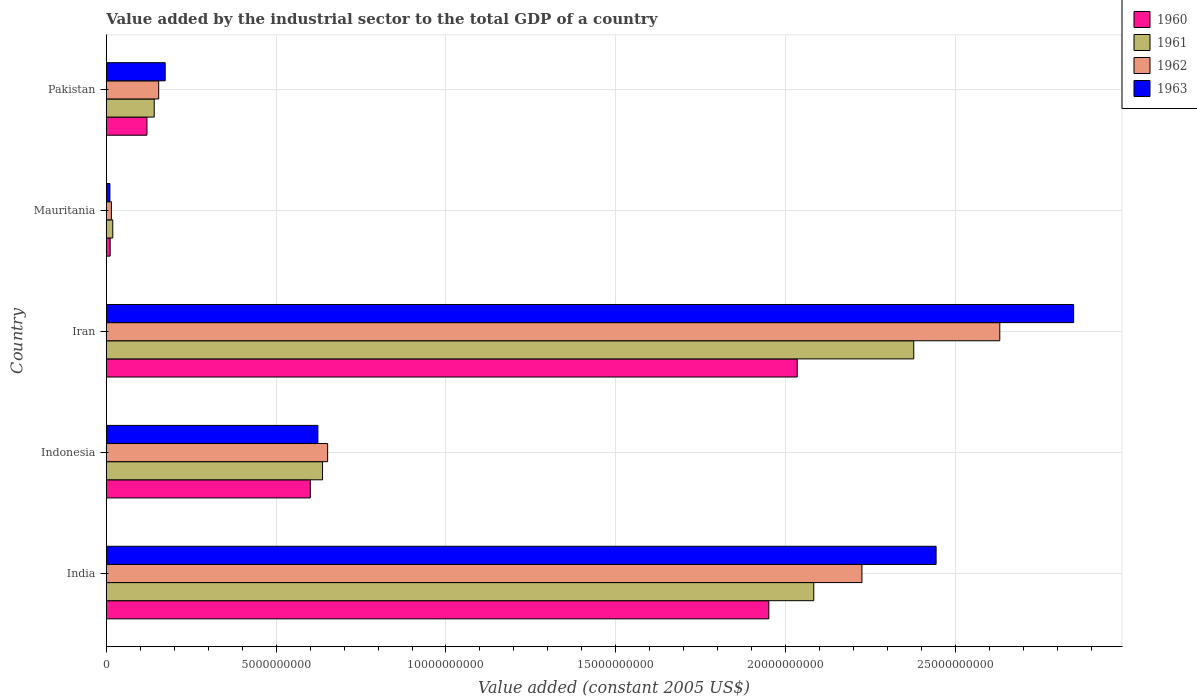How many different coloured bars are there?
Your response must be concise. 4. How many groups of bars are there?
Make the answer very short. 5. Are the number of bars per tick equal to the number of legend labels?
Your response must be concise. Yes. Are the number of bars on each tick of the Y-axis equal?
Keep it short and to the point. Yes. How many bars are there on the 5th tick from the bottom?
Offer a very short reply. 4. What is the value added by the industrial sector in 1960 in Mauritania?
Your answer should be very brief. 1.15e+08. Across all countries, what is the maximum value added by the industrial sector in 1960?
Your response must be concise. 2.03e+1. Across all countries, what is the minimum value added by the industrial sector in 1962?
Give a very brief answer. 1.51e+08. In which country was the value added by the industrial sector in 1963 maximum?
Make the answer very short. Iran. In which country was the value added by the industrial sector in 1963 minimum?
Your answer should be compact. Mauritania. What is the total value added by the industrial sector in 1962 in the graph?
Provide a succinct answer. 5.68e+1. What is the difference between the value added by the industrial sector in 1960 in India and that in Mauritania?
Your response must be concise. 1.94e+1. What is the difference between the value added by the industrial sector in 1961 in Indonesia and the value added by the industrial sector in 1962 in Pakistan?
Provide a short and direct response. 4.82e+09. What is the average value added by the industrial sector in 1960 per country?
Your answer should be compact. 9.43e+09. What is the difference between the value added by the industrial sector in 1961 and value added by the industrial sector in 1962 in India?
Make the answer very short. -1.42e+09. What is the ratio of the value added by the industrial sector in 1963 in India to that in Mauritania?
Your answer should be compact. 225.7. Is the value added by the industrial sector in 1961 in India less than that in Pakistan?
Your answer should be very brief. No. Is the difference between the value added by the industrial sector in 1961 in Iran and Pakistan greater than the difference between the value added by the industrial sector in 1962 in Iran and Pakistan?
Make the answer very short. No. What is the difference between the highest and the second highest value added by the industrial sector in 1960?
Keep it short and to the point. 8.36e+08. What is the difference between the highest and the lowest value added by the industrial sector in 1961?
Offer a terse response. 2.36e+1. Is it the case that in every country, the sum of the value added by the industrial sector in 1960 and value added by the industrial sector in 1962 is greater than the value added by the industrial sector in 1961?
Provide a short and direct response. Yes. How many bars are there?
Offer a terse response. 20. How many countries are there in the graph?
Make the answer very short. 5. What is the difference between two consecutive major ticks on the X-axis?
Provide a succinct answer. 5.00e+09. How many legend labels are there?
Offer a very short reply. 4. How are the legend labels stacked?
Provide a short and direct response. Vertical. What is the title of the graph?
Offer a terse response. Value added by the industrial sector to the total GDP of a country. What is the label or title of the X-axis?
Keep it short and to the point. Value added (constant 2005 US$). What is the label or title of the Y-axis?
Ensure brevity in your answer.  Country. What is the Value added (constant 2005 US$) in 1960 in India?
Offer a very short reply. 1.95e+1. What is the Value added (constant 2005 US$) in 1961 in India?
Provide a short and direct response. 2.08e+1. What is the Value added (constant 2005 US$) in 1962 in India?
Your answer should be compact. 2.22e+1. What is the Value added (constant 2005 US$) in 1963 in India?
Your answer should be very brief. 2.44e+1. What is the Value added (constant 2005 US$) of 1960 in Indonesia?
Provide a short and direct response. 6.01e+09. What is the Value added (constant 2005 US$) in 1961 in Indonesia?
Give a very brief answer. 6.37e+09. What is the Value added (constant 2005 US$) in 1962 in Indonesia?
Your answer should be very brief. 6.52e+09. What is the Value added (constant 2005 US$) of 1963 in Indonesia?
Your answer should be compact. 6.23e+09. What is the Value added (constant 2005 US$) in 1960 in Iran?
Ensure brevity in your answer.  2.03e+1. What is the Value added (constant 2005 US$) of 1961 in Iran?
Offer a terse response. 2.38e+1. What is the Value added (constant 2005 US$) of 1962 in Iran?
Your answer should be very brief. 2.63e+1. What is the Value added (constant 2005 US$) in 1963 in Iran?
Make the answer very short. 2.85e+1. What is the Value added (constant 2005 US$) in 1960 in Mauritania?
Your answer should be very brief. 1.15e+08. What is the Value added (constant 2005 US$) in 1961 in Mauritania?
Keep it short and to the point. 1.92e+08. What is the Value added (constant 2005 US$) of 1962 in Mauritania?
Give a very brief answer. 1.51e+08. What is the Value added (constant 2005 US$) in 1963 in Mauritania?
Provide a succinct answer. 1.08e+08. What is the Value added (constant 2005 US$) in 1960 in Pakistan?
Give a very brief answer. 1.20e+09. What is the Value added (constant 2005 US$) in 1961 in Pakistan?
Your answer should be very brief. 1.41e+09. What is the Value added (constant 2005 US$) in 1962 in Pakistan?
Your response must be concise. 1.54e+09. What is the Value added (constant 2005 US$) of 1963 in Pakistan?
Keep it short and to the point. 1.74e+09. Across all countries, what is the maximum Value added (constant 2005 US$) in 1960?
Provide a short and direct response. 2.03e+1. Across all countries, what is the maximum Value added (constant 2005 US$) of 1961?
Your answer should be compact. 2.38e+1. Across all countries, what is the maximum Value added (constant 2005 US$) of 1962?
Ensure brevity in your answer.  2.63e+1. Across all countries, what is the maximum Value added (constant 2005 US$) of 1963?
Provide a succinct answer. 2.85e+1. Across all countries, what is the minimum Value added (constant 2005 US$) in 1960?
Make the answer very short. 1.15e+08. Across all countries, what is the minimum Value added (constant 2005 US$) of 1961?
Offer a very short reply. 1.92e+08. Across all countries, what is the minimum Value added (constant 2005 US$) of 1962?
Give a very brief answer. 1.51e+08. Across all countries, what is the minimum Value added (constant 2005 US$) in 1963?
Your response must be concise. 1.08e+08. What is the total Value added (constant 2005 US$) of 1960 in the graph?
Provide a short and direct response. 4.72e+1. What is the total Value added (constant 2005 US$) of 1961 in the graph?
Give a very brief answer. 5.26e+1. What is the total Value added (constant 2005 US$) of 1962 in the graph?
Provide a succinct answer. 5.68e+1. What is the total Value added (constant 2005 US$) in 1963 in the graph?
Offer a very short reply. 6.10e+1. What is the difference between the Value added (constant 2005 US$) in 1960 in India and that in Indonesia?
Your answer should be very brief. 1.35e+1. What is the difference between the Value added (constant 2005 US$) of 1961 in India and that in Indonesia?
Offer a very short reply. 1.45e+1. What is the difference between the Value added (constant 2005 US$) of 1962 in India and that in Indonesia?
Ensure brevity in your answer.  1.57e+1. What is the difference between the Value added (constant 2005 US$) in 1963 in India and that in Indonesia?
Make the answer very short. 1.82e+1. What is the difference between the Value added (constant 2005 US$) of 1960 in India and that in Iran?
Ensure brevity in your answer.  -8.36e+08. What is the difference between the Value added (constant 2005 US$) of 1961 in India and that in Iran?
Provide a short and direct response. -2.94e+09. What is the difference between the Value added (constant 2005 US$) in 1962 in India and that in Iran?
Offer a very short reply. -4.06e+09. What is the difference between the Value added (constant 2005 US$) in 1963 in India and that in Iran?
Your answer should be very brief. -4.05e+09. What is the difference between the Value added (constant 2005 US$) of 1960 in India and that in Mauritania?
Keep it short and to the point. 1.94e+1. What is the difference between the Value added (constant 2005 US$) in 1961 in India and that in Mauritania?
Ensure brevity in your answer.  2.06e+1. What is the difference between the Value added (constant 2005 US$) in 1962 in India and that in Mauritania?
Provide a succinct answer. 2.21e+1. What is the difference between the Value added (constant 2005 US$) in 1963 in India and that in Mauritania?
Your answer should be compact. 2.43e+1. What is the difference between the Value added (constant 2005 US$) of 1960 in India and that in Pakistan?
Your response must be concise. 1.83e+1. What is the difference between the Value added (constant 2005 US$) in 1961 in India and that in Pakistan?
Provide a short and direct response. 1.94e+1. What is the difference between the Value added (constant 2005 US$) in 1962 in India and that in Pakistan?
Your response must be concise. 2.07e+1. What is the difference between the Value added (constant 2005 US$) in 1963 in India and that in Pakistan?
Your response must be concise. 2.27e+1. What is the difference between the Value added (constant 2005 US$) in 1960 in Indonesia and that in Iran?
Your answer should be very brief. -1.43e+1. What is the difference between the Value added (constant 2005 US$) of 1961 in Indonesia and that in Iran?
Provide a succinct answer. -1.74e+1. What is the difference between the Value added (constant 2005 US$) in 1962 in Indonesia and that in Iran?
Provide a succinct answer. -1.98e+1. What is the difference between the Value added (constant 2005 US$) in 1963 in Indonesia and that in Iran?
Your answer should be very brief. -2.22e+1. What is the difference between the Value added (constant 2005 US$) in 1960 in Indonesia and that in Mauritania?
Make the answer very short. 5.89e+09. What is the difference between the Value added (constant 2005 US$) in 1961 in Indonesia and that in Mauritania?
Offer a very short reply. 6.17e+09. What is the difference between the Value added (constant 2005 US$) of 1962 in Indonesia and that in Mauritania?
Offer a terse response. 6.37e+09. What is the difference between the Value added (constant 2005 US$) of 1963 in Indonesia and that in Mauritania?
Provide a short and direct response. 6.12e+09. What is the difference between the Value added (constant 2005 US$) in 1960 in Indonesia and that in Pakistan?
Provide a short and direct response. 4.81e+09. What is the difference between the Value added (constant 2005 US$) in 1961 in Indonesia and that in Pakistan?
Offer a very short reply. 4.96e+09. What is the difference between the Value added (constant 2005 US$) of 1962 in Indonesia and that in Pakistan?
Give a very brief answer. 4.97e+09. What is the difference between the Value added (constant 2005 US$) of 1963 in Indonesia and that in Pakistan?
Offer a very short reply. 4.49e+09. What is the difference between the Value added (constant 2005 US$) of 1960 in Iran and that in Mauritania?
Offer a terse response. 2.02e+1. What is the difference between the Value added (constant 2005 US$) of 1961 in Iran and that in Mauritania?
Your answer should be very brief. 2.36e+1. What is the difference between the Value added (constant 2005 US$) of 1962 in Iran and that in Mauritania?
Provide a short and direct response. 2.62e+1. What is the difference between the Value added (constant 2005 US$) of 1963 in Iran and that in Mauritania?
Provide a succinct answer. 2.84e+1. What is the difference between the Value added (constant 2005 US$) of 1960 in Iran and that in Pakistan?
Offer a terse response. 1.91e+1. What is the difference between the Value added (constant 2005 US$) in 1961 in Iran and that in Pakistan?
Give a very brief answer. 2.24e+1. What is the difference between the Value added (constant 2005 US$) of 1962 in Iran and that in Pakistan?
Ensure brevity in your answer.  2.48e+1. What is the difference between the Value added (constant 2005 US$) of 1963 in Iran and that in Pakistan?
Provide a short and direct response. 2.67e+1. What is the difference between the Value added (constant 2005 US$) in 1960 in Mauritania and that in Pakistan?
Ensure brevity in your answer.  -1.08e+09. What is the difference between the Value added (constant 2005 US$) in 1961 in Mauritania and that in Pakistan?
Give a very brief answer. -1.22e+09. What is the difference between the Value added (constant 2005 US$) of 1962 in Mauritania and that in Pakistan?
Provide a succinct answer. -1.39e+09. What is the difference between the Value added (constant 2005 US$) in 1963 in Mauritania and that in Pakistan?
Ensure brevity in your answer.  -1.63e+09. What is the difference between the Value added (constant 2005 US$) of 1960 in India and the Value added (constant 2005 US$) of 1961 in Indonesia?
Your answer should be very brief. 1.31e+1. What is the difference between the Value added (constant 2005 US$) of 1960 in India and the Value added (constant 2005 US$) of 1962 in Indonesia?
Ensure brevity in your answer.  1.30e+1. What is the difference between the Value added (constant 2005 US$) in 1960 in India and the Value added (constant 2005 US$) in 1963 in Indonesia?
Provide a short and direct response. 1.33e+1. What is the difference between the Value added (constant 2005 US$) in 1961 in India and the Value added (constant 2005 US$) in 1962 in Indonesia?
Ensure brevity in your answer.  1.43e+1. What is the difference between the Value added (constant 2005 US$) in 1961 in India and the Value added (constant 2005 US$) in 1963 in Indonesia?
Offer a very short reply. 1.46e+1. What is the difference between the Value added (constant 2005 US$) of 1962 in India and the Value added (constant 2005 US$) of 1963 in Indonesia?
Provide a succinct answer. 1.60e+1. What is the difference between the Value added (constant 2005 US$) of 1960 in India and the Value added (constant 2005 US$) of 1961 in Iran?
Keep it short and to the point. -4.27e+09. What is the difference between the Value added (constant 2005 US$) of 1960 in India and the Value added (constant 2005 US$) of 1962 in Iran?
Give a very brief answer. -6.80e+09. What is the difference between the Value added (constant 2005 US$) in 1960 in India and the Value added (constant 2005 US$) in 1963 in Iran?
Offer a terse response. -8.97e+09. What is the difference between the Value added (constant 2005 US$) in 1961 in India and the Value added (constant 2005 US$) in 1962 in Iran?
Ensure brevity in your answer.  -5.48e+09. What is the difference between the Value added (constant 2005 US$) in 1961 in India and the Value added (constant 2005 US$) in 1963 in Iran?
Your answer should be compact. -7.65e+09. What is the difference between the Value added (constant 2005 US$) in 1962 in India and the Value added (constant 2005 US$) in 1963 in Iran?
Provide a short and direct response. -6.23e+09. What is the difference between the Value added (constant 2005 US$) of 1960 in India and the Value added (constant 2005 US$) of 1961 in Mauritania?
Keep it short and to the point. 1.93e+1. What is the difference between the Value added (constant 2005 US$) of 1960 in India and the Value added (constant 2005 US$) of 1962 in Mauritania?
Your answer should be very brief. 1.94e+1. What is the difference between the Value added (constant 2005 US$) of 1960 in India and the Value added (constant 2005 US$) of 1963 in Mauritania?
Offer a terse response. 1.94e+1. What is the difference between the Value added (constant 2005 US$) of 1961 in India and the Value added (constant 2005 US$) of 1962 in Mauritania?
Offer a very short reply. 2.07e+1. What is the difference between the Value added (constant 2005 US$) of 1961 in India and the Value added (constant 2005 US$) of 1963 in Mauritania?
Provide a short and direct response. 2.07e+1. What is the difference between the Value added (constant 2005 US$) in 1962 in India and the Value added (constant 2005 US$) in 1963 in Mauritania?
Your answer should be very brief. 2.21e+1. What is the difference between the Value added (constant 2005 US$) in 1960 in India and the Value added (constant 2005 US$) in 1961 in Pakistan?
Offer a terse response. 1.81e+1. What is the difference between the Value added (constant 2005 US$) in 1960 in India and the Value added (constant 2005 US$) in 1962 in Pakistan?
Keep it short and to the point. 1.80e+1. What is the difference between the Value added (constant 2005 US$) of 1960 in India and the Value added (constant 2005 US$) of 1963 in Pakistan?
Your response must be concise. 1.78e+1. What is the difference between the Value added (constant 2005 US$) of 1961 in India and the Value added (constant 2005 US$) of 1962 in Pakistan?
Your answer should be compact. 1.93e+1. What is the difference between the Value added (constant 2005 US$) in 1961 in India and the Value added (constant 2005 US$) in 1963 in Pakistan?
Keep it short and to the point. 1.91e+1. What is the difference between the Value added (constant 2005 US$) in 1962 in India and the Value added (constant 2005 US$) in 1963 in Pakistan?
Offer a very short reply. 2.05e+1. What is the difference between the Value added (constant 2005 US$) in 1960 in Indonesia and the Value added (constant 2005 US$) in 1961 in Iran?
Your answer should be very brief. -1.78e+1. What is the difference between the Value added (constant 2005 US$) of 1960 in Indonesia and the Value added (constant 2005 US$) of 1962 in Iran?
Offer a very short reply. -2.03e+1. What is the difference between the Value added (constant 2005 US$) in 1960 in Indonesia and the Value added (constant 2005 US$) in 1963 in Iran?
Ensure brevity in your answer.  -2.25e+1. What is the difference between the Value added (constant 2005 US$) in 1961 in Indonesia and the Value added (constant 2005 US$) in 1962 in Iran?
Your response must be concise. -1.99e+1. What is the difference between the Value added (constant 2005 US$) in 1961 in Indonesia and the Value added (constant 2005 US$) in 1963 in Iran?
Give a very brief answer. -2.21e+1. What is the difference between the Value added (constant 2005 US$) in 1962 in Indonesia and the Value added (constant 2005 US$) in 1963 in Iran?
Ensure brevity in your answer.  -2.20e+1. What is the difference between the Value added (constant 2005 US$) in 1960 in Indonesia and the Value added (constant 2005 US$) in 1961 in Mauritania?
Your response must be concise. 5.81e+09. What is the difference between the Value added (constant 2005 US$) in 1960 in Indonesia and the Value added (constant 2005 US$) in 1962 in Mauritania?
Offer a terse response. 5.86e+09. What is the difference between the Value added (constant 2005 US$) in 1960 in Indonesia and the Value added (constant 2005 US$) in 1963 in Mauritania?
Keep it short and to the point. 5.90e+09. What is the difference between the Value added (constant 2005 US$) in 1961 in Indonesia and the Value added (constant 2005 US$) in 1962 in Mauritania?
Keep it short and to the point. 6.22e+09. What is the difference between the Value added (constant 2005 US$) in 1961 in Indonesia and the Value added (constant 2005 US$) in 1963 in Mauritania?
Your answer should be very brief. 6.26e+09. What is the difference between the Value added (constant 2005 US$) of 1962 in Indonesia and the Value added (constant 2005 US$) of 1963 in Mauritania?
Keep it short and to the point. 6.41e+09. What is the difference between the Value added (constant 2005 US$) of 1960 in Indonesia and the Value added (constant 2005 US$) of 1961 in Pakistan?
Give a very brief answer. 4.60e+09. What is the difference between the Value added (constant 2005 US$) of 1960 in Indonesia and the Value added (constant 2005 US$) of 1962 in Pakistan?
Offer a very short reply. 4.46e+09. What is the difference between the Value added (constant 2005 US$) in 1960 in Indonesia and the Value added (constant 2005 US$) in 1963 in Pakistan?
Offer a terse response. 4.27e+09. What is the difference between the Value added (constant 2005 US$) of 1961 in Indonesia and the Value added (constant 2005 US$) of 1962 in Pakistan?
Keep it short and to the point. 4.82e+09. What is the difference between the Value added (constant 2005 US$) of 1961 in Indonesia and the Value added (constant 2005 US$) of 1963 in Pakistan?
Your answer should be very brief. 4.63e+09. What is the difference between the Value added (constant 2005 US$) in 1962 in Indonesia and the Value added (constant 2005 US$) in 1963 in Pakistan?
Give a very brief answer. 4.78e+09. What is the difference between the Value added (constant 2005 US$) in 1960 in Iran and the Value added (constant 2005 US$) in 1961 in Mauritania?
Ensure brevity in your answer.  2.01e+1. What is the difference between the Value added (constant 2005 US$) of 1960 in Iran and the Value added (constant 2005 US$) of 1962 in Mauritania?
Your response must be concise. 2.02e+1. What is the difference between the Value added (constant 2005 US$) in 1960 in Iran and the Value added (constant 2005 US$) in 1963 in Mauritania?
Provide a short and direct response. 2.02e+1. What is the difference between the Value added (constant 2005 US$) in 1961 in Iran and the Value added (constant 2005 US$) in 1962 in Mauritania?
Your answer should be very brief. 2.36e+1. What is the difference between the Value added (constant 2005 US$) in 1961 in Iran and the Value added (constant 2005 US$) in 1963 in Mauritania?
Provide a succinct answer. 2.37e+1. What is the difference between the Value added (constant 2005 US$) in 1962 in Iran and the Value added (constant 2005 US$) in 1963 in Mauritania?
Your answer should be compact. 2.62e+1. What is the difference between the Value added (constant 2005 US$) in 1960 in Iran and the Value added (constant 2005 US$) in 1961 in Pakistan?
Provide a short and direct response. 1.89e+1. What is the difference between the Value added (constant 2005 US$) in 1960 in Iran and the Value added (constant 2005 US$) in 1962 in Pakistan?
Your answer should be compact. 1.88e+1. What is the difference between the Value added (constant 2005 US$) in 1960 in Iran and the Value added (constant 2005 US$) in 1963 in Pakistan?
Your response must be concise. 1.86e+1. What is the difference between the Value added (constant 2005 US$) in 1961 in Iran and the Value added (constant 2005 US$) in 1962 in Pakistan?
Offer a terse response. 2.22e+1. What is the difference between the Value added (constant 2005 US$) in 1961 in Iran and the Value added (constant 2005 US$) in 1963 in Pakistan?
Your response must be concise. 2.20e+1. What is the difference between the Value added (constant 2005 US$) in 1962 in Iran and the Value added (constant 2005 US$) in 1963 in Pakistan?
Ensure brevity in your answer.  2.46e+1. What is the difference between the Value added (constant 2005 US$) of 1960 in Mauritania and the Value added (constant 2005 US$) of 1961 in Pakistan?
Make the answer very short. -1.30e+09. What is the difference between the Value added (constant 2005 US$) in 1960 in Mauritania and the Value added (constant 2005 US$) in 1962 in Pakistan?
Your response must be concise. -1.43e+09. What is the difference between the Value added (constant 2005 US$) in 1960 in Mauritania and the Value added (constant 2005 US$) in 1963 in Pakistan?
Provide a succinct answer. -1.62e+09. What is the difference between the Value added (constant 2005 US$) of 1961 in Mauritania and the Value added (constant 2005 US$) of 1962 in Pakistan?
Your answer should be compact. -1.35e+09. What is the difference between the Value added (constant 2005 US$) in 1961 in Mauritania and the Value added (constant 2005 US$) in 1963 in Pakistan?
Your answer should be compact. -1.54e+09. What is the difference between the Value added (constant 2005 US$) in 1962 in Mauritania and the Value added (constant 2005 US$) in 1963 in Pakistan?
Offer a terse response. -1.58e+09. What is the average Value added (constant 2005 US$) in 1960 per country?
Provide a succinct answer. 9.43e+09. What is the average Value added (constant 2005 US$) of 1961 per country?
Ensure brevity in your answer.  1.05e+1. What is the average Value added (constant 2005 US$) of 1962 per country?
Ensure brevity in your answer.  1.14e+1. What is the average Value added (constant 2005 US$) in 1963 per country?
Make the answer very short. 1.22e+1. What is the difference between the Value added (constant 2005 US$) of 1960 and Value added (constant 2005 US$) of 1961 in India?
Give a very brief answer. -1.32e+09. What is the difference between the Value added (constant 2005 US$) of 1960 and Value added (constant 2005 US$) of 1962 in India?
Make the answer very short. -2.74e+09. What is the difference between the Value added (constant 2005 US$) in 1960 and Value added (constant 2005 US$) in 1963 in India?
Provide a short and direct response. -4.92e+09. What is the difference between the Value added (constant 2005 US$) in 1961 and Value added (constant 2005 US$) in 1962 in India?
Your answer should be compact. -1.42e+09. What is the difference between the Value added (constant 2005 US$) of 1961 and Value added (constant 2005 US$) of 1963 in India?
Offer a terse response. -3.60e+09. What is the difference between the Value added (constant 2005 US$) in 1962 and Value added (constant 2005 US$) in 1963 in India?
Provide a succinct answer. -2.18e+09. What is the difference between the Value added (constant 2005 US$) of 1960 and Value added (constant 2005 US$) of 1961 in Indonesia?
Give a very brief answer. -3.60e+08. What is the difference between the Value added (constant 2005 US$) of 1960 and Value added (constant 2005 US$) of 1962 in Indonesia?
Keep it short and to the point. -5.10e+08. What is the difference between the Value added (constant 2005 US$) in 1960 and Value added (constant 2005 US$) in 1963 in Indonesia?
Provide a succinct answer. -2.22e+08. What is the difference between the Value added (constant 2005 US$) of 1961 and Value added (constant 2005 US$) of 1962 in Indonesia?
Provide a short and direct response. -1.50e+08. What is the difference between the Value added (constant 2005 US$) in 1961 and Value added (constant 2005 US$) in 1963 in Indonesia?
Provide a succinct answer. 1.38e+08. What is the difference between the Value added (constant 2005 US$) of 1962 and Value added (constant 2005 US$) of 1963 in Indonesia?
Keep it short and to the point. 2.88e+08. What is the difference between the Value added (constant 2005 US$) of 1960 and Value added (constant 2005 US$) of 1961 in Iran?
Keep it short and to the point. -3.43e+09. What is the difference between the Value added (constant 2005 US$) in 1960 and Value added (constant 2005 US$) in 1962 in Iran?
Offer a terse response. -5.96e+09. What is the difference between the Value added (constant 2005 US$) of 1960 and Value added (constant 2005 US$) of 1963 in Iran?
Your answer should be compact. -8.14e+09. What is the difference between the Value added (constant 2005 US$) in 1961 and Value added (constant 2005 US$) in 1962 in Iran?
Ensure brevity in your answer.  -2.53e+09. What is the difference between the Value added (constant 2005 US$) in 1961 and Value added (constant 2005 US$) in 1963 in Iran?
Give a very brief answer. -4.71e+09. What is the difference between the Value added (constant 2005 US$) in 1962 and Value added (constant 2005 US$) in 1963 in Iran?
Your response must be concise. -2.17e+09. What is the difference between the Value added (constant 2005 US$) of 1960 and Value added (constant 2005 US$) of 1961 in Mauritania?
Ensure brevity in your answer.  -7.68e+07. What is the difference between the Value added (constant 2005 US$) of 1960 and Value added (constant 2005 US$) of 1962 in Mauritania?
Give a very brief answer. -3.59e+07. What is the difference between the Value added (constant 2005 US$) of 1960 and Value added (constant 2005 US$) of 1963 in Mauritania?
Offer a terse response. 7.13e+06. What is the difference between the Value added (constant 2005 US$) of 1961 and Value added (constant 2005 US$) of 1962 in Mauritania?
Ensure brevity in your answer.  4.09e+07. What is the difference between the Value added (constant 2005 US$) in 1961 and Value added (constant 2005 US$) in 1963 in Mauritania?
Offer a very short reply. 8.39e+07. What is the difference between the Value added (constant 2005 US$) in 1962 and Value added (constant 2005 US$) in 1963 in Mauritania?
Offer a terse response. 4.31e+07. What is the difference between the Value added (constant 2005 US$) in 1960 and Value added (constant 2005 US$) in 1961 in Pakistan?
Provide a short and direct response. -2.14e+08. What is the difference between the Value added (constant 2005 US$) in 1960 and Value added (constant 2005 US$) in 1962 in Pakistan?
Give a very brief answer. -3.45e+08. What is the difference between the Value added (constant 2005 US$) in 1960 and Value added (constant 2005 US$) in 1963 in Pakistan?
Ensure brevity in your answer.  -5.37e+08. What is the difference between the Value added (constant 2005 US$) in 1961 and Value added (constant 2005 US$) in 1962 in Pakistan?
Ensure brevity in your answer.  -1.32e+08. What is the difference between the Value added (constant 2005 US$) in 1961 and Value added (constant 2005 US$) in 1963 in Pakistan?
Ensure brevity in your answer.  -3.23e+08. What is the difference between the Value added (constant 2005 US$) of 1962 and Value added (constant 2005 US$) of 1963 in Pakistan?
Give a very brief answer. -1.92e+08. What is the ratio of the Value added (constant 2005 US$) of 1960 in India to that in Indonesia?
Your answer should be very brief. 3.25. What is the ratio of the Value added (constant 2005 US$) of 1961 in India to that in Indonesia?
Your response must be concise. 3.27. What is the ratio of the Value added (constant 2005 US$) of 1962 in India to that in Indonesia?
Make the answer very short. 3.41. What is the ratio of the Value added (constant 2005 US$) of 1963 in India to that in Indonesia?
Keep it short and to the point. 3.92. What is the ratio of the Value added (constant 2005 US$) of 1960 in India to that in Iran?
Ensure brevity in your answer.  0.96. What is the ratio of the Value added (constant 2005 US$) of 1961 in India to that in Iran?
Provide a succinct answer. 0.88. What is the ratio of the Value added (constant 2005 US$) of 1962 in India to that in Iran?
Give a very brief answer. 0.85. What is the ratio of the Value added (constant 2005 US$) in 1963 in India to that in Iran?
Offer a terse response. 0.86. What is the ratio of the Value added (constant 2005 US$) of 1960 in India to that in Mauritania?
Your response must be concise. 169.07. What is the ratio of the Value added (constant 2005 US$) in 1961 in India to that in Mauritania?
Your answer should be very brief. 108.39. What is the ratio of the Value added (constant 2005 US$) in 1962 in India to that in Mauritania?
Offer a very short reply. 147.02. What is the ratio of the Value added (constant 2005 US$) in 1963 in India to that in Mauritania?
Make the answer very short. 225.7. What is the ratio of the Value added (constant 2005 US$) of 1960 in India to that in Pakistan?
Your answer should be compact. 16.28. What is the ratio of the Value added (constant 2005 US$) of 1961 in India to that in Pakistan?
Keep it short and to the point. 14.75. What is the ratio of the Value added (constant 2005 US$) in 1962 in India to that in Pakistan?
Offer a terse response. 14.41. What is the ratio of the Value added (constant 2005 US$) in 1963 in India to that in Pakistan?
Your answer should be compact. 14.08. What is the ratio of the Value added (constant 2005 US$) of 1960 in Indonesia to that in Iran?
Your response must be concise. 0.3. What is the ratio of the Value added (constant 2005 US$) in 1961 in Indonesia to that in Iran?
Provide a succinct answer. 0.27. What is the ratio of the Value added (constant 2005 US$) in 1962 in Indonesia to that in Iran?
Keep it short and to the point. 0.25. What is the ratio of the Value added (constant 2005 US$) in 1963 in Indonesia to that in Iran?
Ensure brevity in your answer.  0.22. What is the ratio of the Value added (constant 2005 US$) of 1960 in Indonesia to that in Mauritania?
Provide a short and direct response. 52.07. What is the ratio of the Value added (constant 2005 US$) in 1961 in Indonesia to that in Mauritania?
Provide a succinct answer. 33.14. What is the ratio of the Value added (constant 2005 US$) of 1962 in Indonesia to that in Mauritania?
Keep it short and to the point. 43.07. What is the ratio of the Value added (constant 2005 US$) in 1963 in Indonesia to that in Mauritania?
Give a very brief answer. 57.56. What is the ratio of the Value added (constant 2005 US$) in 1960 in Indonesia to that in Pakistan?
Provide a succinct answer. 5.01. What is the ratio of the Value added (constant 2005 US$) in 1961 in Indonesia to that in Pakistan?
Your answer should be compact. 4.51. What is the ratio of the Value added (constant 2005 US$) of 1962 in Indonesia to that in Pakistan?
Make the answer very short. 4.22. What is the ratio of the Value added (constant 2005 US$) of 1963 in Indonesia to that in Pakistan?
Keep it short and to the point. 3.59. What is the ratio of the Value added (constant 2005 US$) of 1960 in Iran to that in Mauritania?
Offer a very short reply. 176.32. What is the ratio of the Value added (constant 2005 US$) in 1961 in Iran to that in Mauritania?
Provide a succinct answer. 123.7. What is the ratio of the Value added (constant 2005 US$) of 1962 in Iran to that in Mauritania?
Offer a terse response. 173.84. What is the ratio of the Value added (constant 2005 US$) in 1963 in Iran to that in Mauritania?
Your response must be concise. 263.11. What is the ratio of the Value added (constant 2005 US$) of 1960 in Iran to that in Pakistan?
Your answer should be very brief. 16.98. What is the ratio of the Value added (constant 2005 US$) of 1961 in Iran to that in Pakistan?
Your response must be concise. 16.84. What is the ratio of the Value added (constant 2005 US$) of 1962 in Iran to that in Pakistan?
Make the answer very short. 17.04. What is the ratio of the Value added (constant 2005 US$) in 1963 in Iran to that in Pakistan?
Offer a very short reply. 16.41. What is the ratio of the Value added (constant 2005 US$) in 1960 in Mauritania to that in Pakistan?
Your answer should be compact. 0.1. What is the ratio of the Value added (constant 2005 US$) of 1961 in Mauritania to that in Pakistan?
Ensure brevity in your answer.  0.14. What is the ratio of the Value added (constant 2005 US$) in 1962 in Mauritania to that in Pakistan?
Give a very brief answer. 0.1. What is the ratio of the Value added (constant 2005 US$) in 1963 in Mauritania to that in Pakistan?
Give a very brief answer. 0.06. What is the difference between the highest and the second highest Value added (constant 2005 US$) in 1960?
Your answer should be very brief. 8.36e+08. What is the difference between the highest and the second highest Value added (constant 2005 US$) in 1961?
Your answer should be very brief. 2.94e+09. What is the difference between the highest and the second highest Value added (constant 2005 US$) of 1962?
Make the answer very short. 4.06e+09. What is the difference between the highest and the second highest Value added (constant 2005 US$) of 1963?
Provide a short and direct response. 4.05e+09. What is the difference between the highest and the lowest Value added (constant 2005 US$) in 1960?
Ensure brevity in your answer.  2.02e+1. What is the difference between the highest and the lowest Value added (constant 2005 US$) of 1961?
Your answer should be compact. 2.36e+1. What is the difference between the highest and the lowest Value added (constant 2005 US$) in 1962?
Offer a terse response. 2.62e+1. What is the difference between the highest and the lowest Value added (constant 2005 US$) of 1963?
Give a very brief answer. 2.84e+1. 